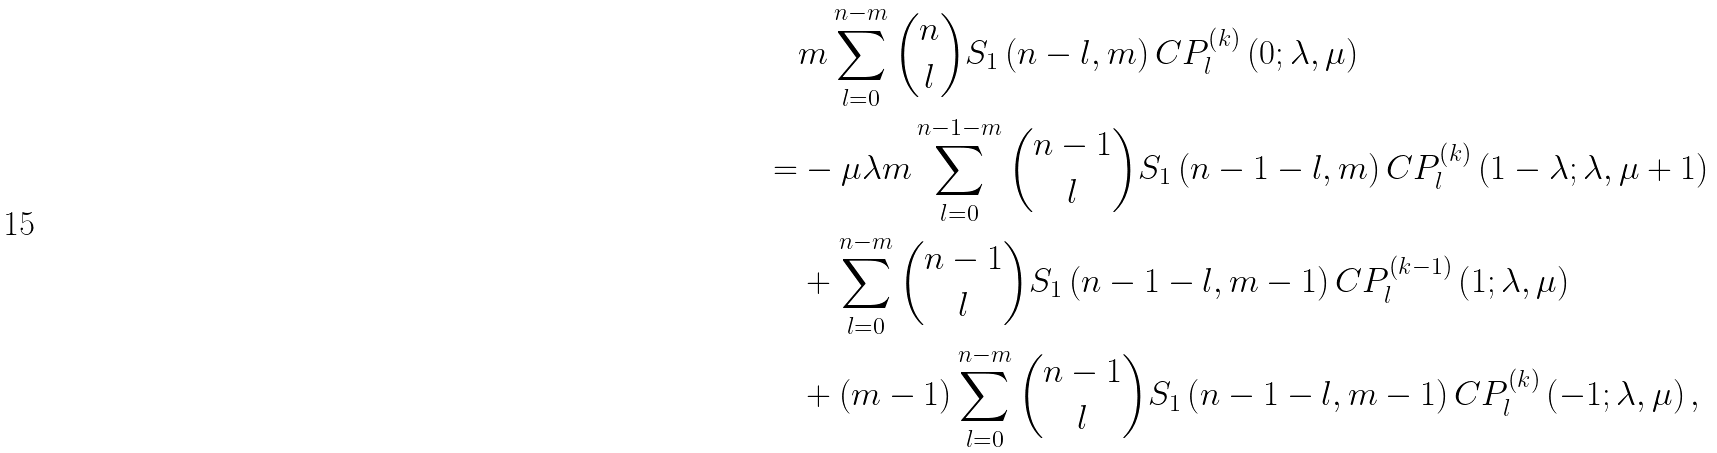Convert formula to latex. <formula><loc_0><loc_0><loc_500><loc_500>& m \sum _ { l = 0 } ^ { n - m } \binom { n } { l } S _ { 1 } \left ( n - l , m \right ) C P _ { l } ^ { \left ( k \right ) } \left ( 0 ; \lambda , \mu \right ) \\ = & - \mu \lambda m \sum _ { l = 0 } ^ { n - 1 - m } \binom { n - 1 } { l } S _ { 1 } \left ( n - 1 - l , m \right ) C P _ { l } ^ { \left ( k \right ) } \left ( 1 - \lambda ; \lambda , \mu + 1 \right ) \\ & + \sum _ { l = 0 } ^ { n - m } \binom { n - 1 } { l } S _ { 1 } \left ( n - 1 - l , m - 1 \right ) C P _ { l } ^ { \left ( k - 1 \right ) } \left ( 1 ; \lambda , \mu \right ) \\ & + \left ( m - 1 \right ) \sum _ { l = 0 } ^ { n - m } \binom { n - 1 } { l } S _ { 1 } \left ( n - 1 - l , m - 1 \right ) C P _ { l } ^ { \left ( k \right ) } \left ( - 1 ; \lambda , \mu \right ) ,</formula> 